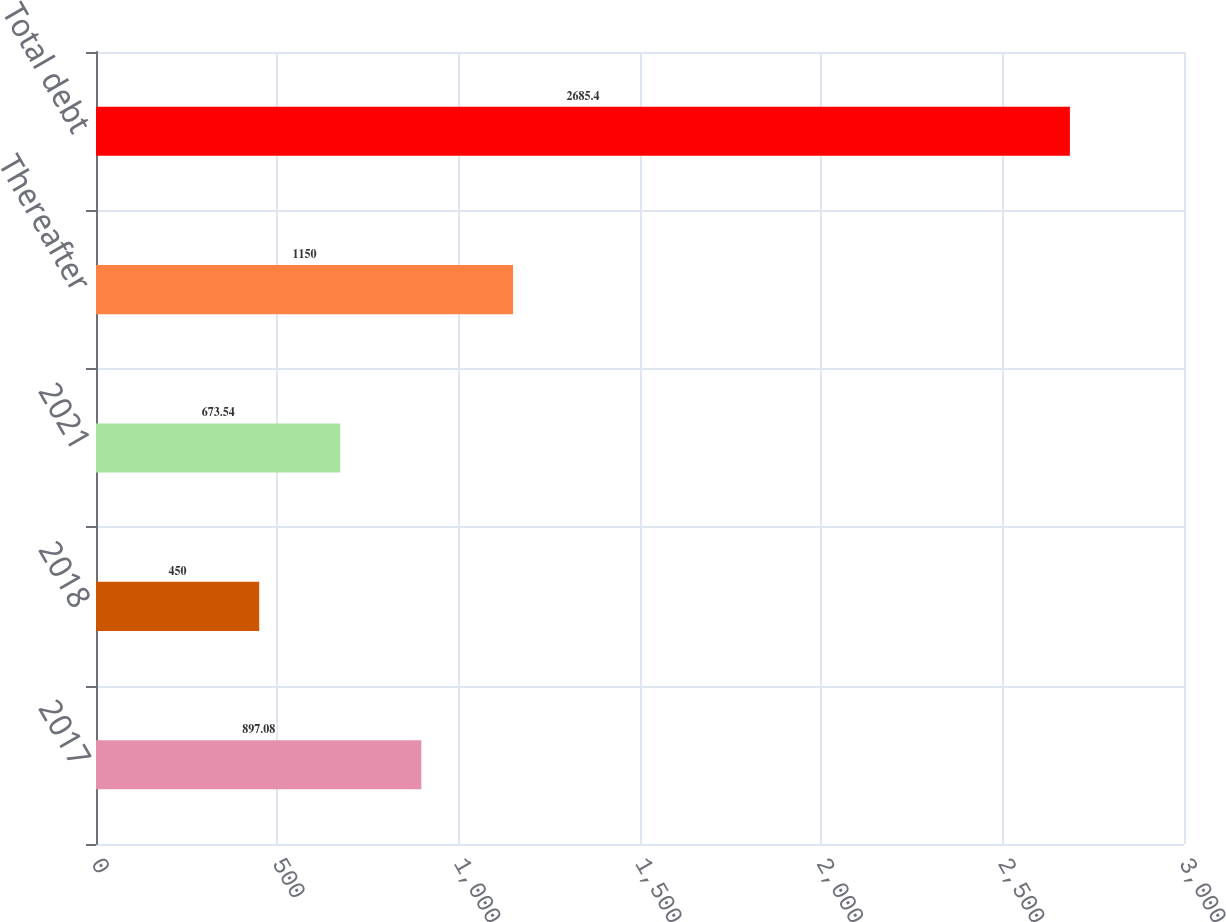<chart> <loc_0><loc_0><loc_500><loc_500><bar_chart><fcel>2017<fcel>2018<fcel>2021<fcel>Thereafter<fcel>Total debt<nl><fcel>897.08<fcel>450<fcel>673.54<fcel>1150<fcel>2685.4<nl></chart> 